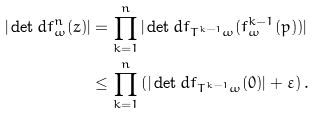Convert formula to latex. <formula><loc_0><loc_0><loc_500><loc_500>| \det d f ^ { n } _ { \omega } ( z ) | & = \prod _ { k = 1 } ^ { n } | \det d f _ { T ^ { k - 1 } \omega } ( f _ { \omega } ^ { k - 1 } ( p ) ) | \\ & \leq \prod _ { k = 1 } ^ { n } \left ( | \det d f _ { T ^ { k - 1 } \omega } ( 0 ) | + \varepsilon \right ) .</formula> 